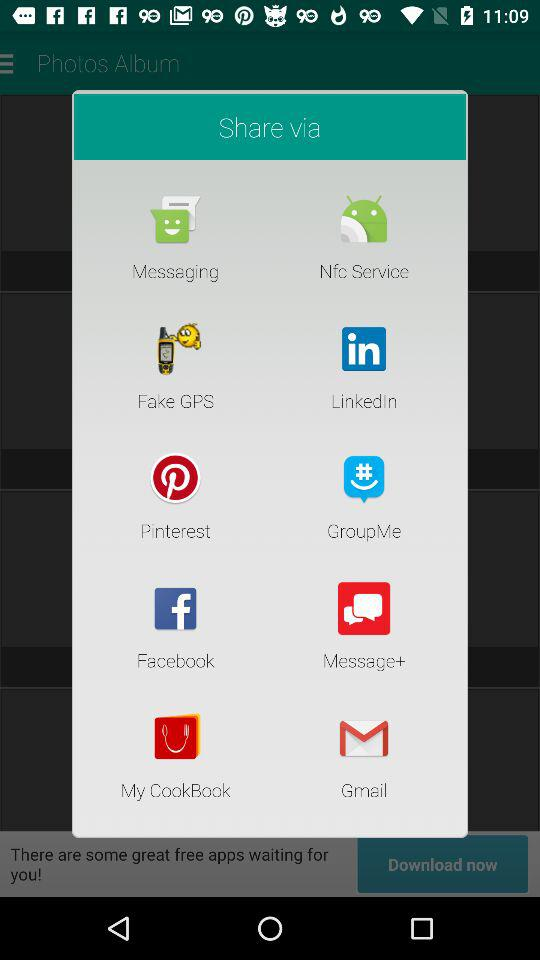What application can I use to share? We can use: "Messaging", "Nfc Service", "Fake GPS", "LinkedIn", "Pinterest", "GroupMe", "Facebook", "Message+", "My CookBook", and "Gmail" to share. 